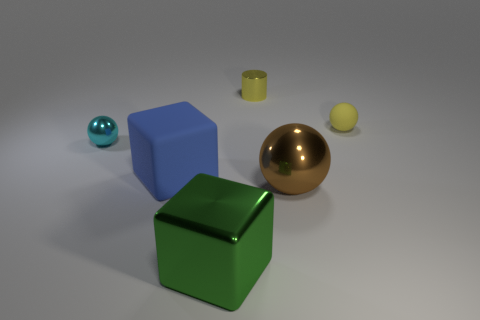Are there fewer green metallic cubes in front of the metal cube than small yellow balls that are behind the yellow sphere?
Give a very brief answer. No. Does the large metallic object that is behind the green metallic cube have the same shape as the tiny yellow thing behind the small yellow ball?
Offer a terse response. No. What is the shape of the large shiny thing to the right of the big shiny object that is to the left of the small yellow cylinder?
Offer a very short reply. Sphere. What is the size of the cylinder that is the same color as the small matte sphere?
Your answer should be very brief. Small. Are there any big blocks that have the same material as the small yellow sphere?
Provide a succinct answer. Yes. There is a cube on the left side of the green metal cube; what material is it?
Keep it short and to the point. Rubber. What is the green thing made of?
Provide a short and direct response. Metal. Are the ball that is to the right of the large brown object and the blue object made of the same material?
Your response must be concise. Yes. Is the number of blue matte things on the right side of the big blue rubber thing less than the number of big blue blocks?
Give a very brief answer. Yes. The cylinder that is the same size as the cyan object is what color?
Your answer should be compact. Yellow. 